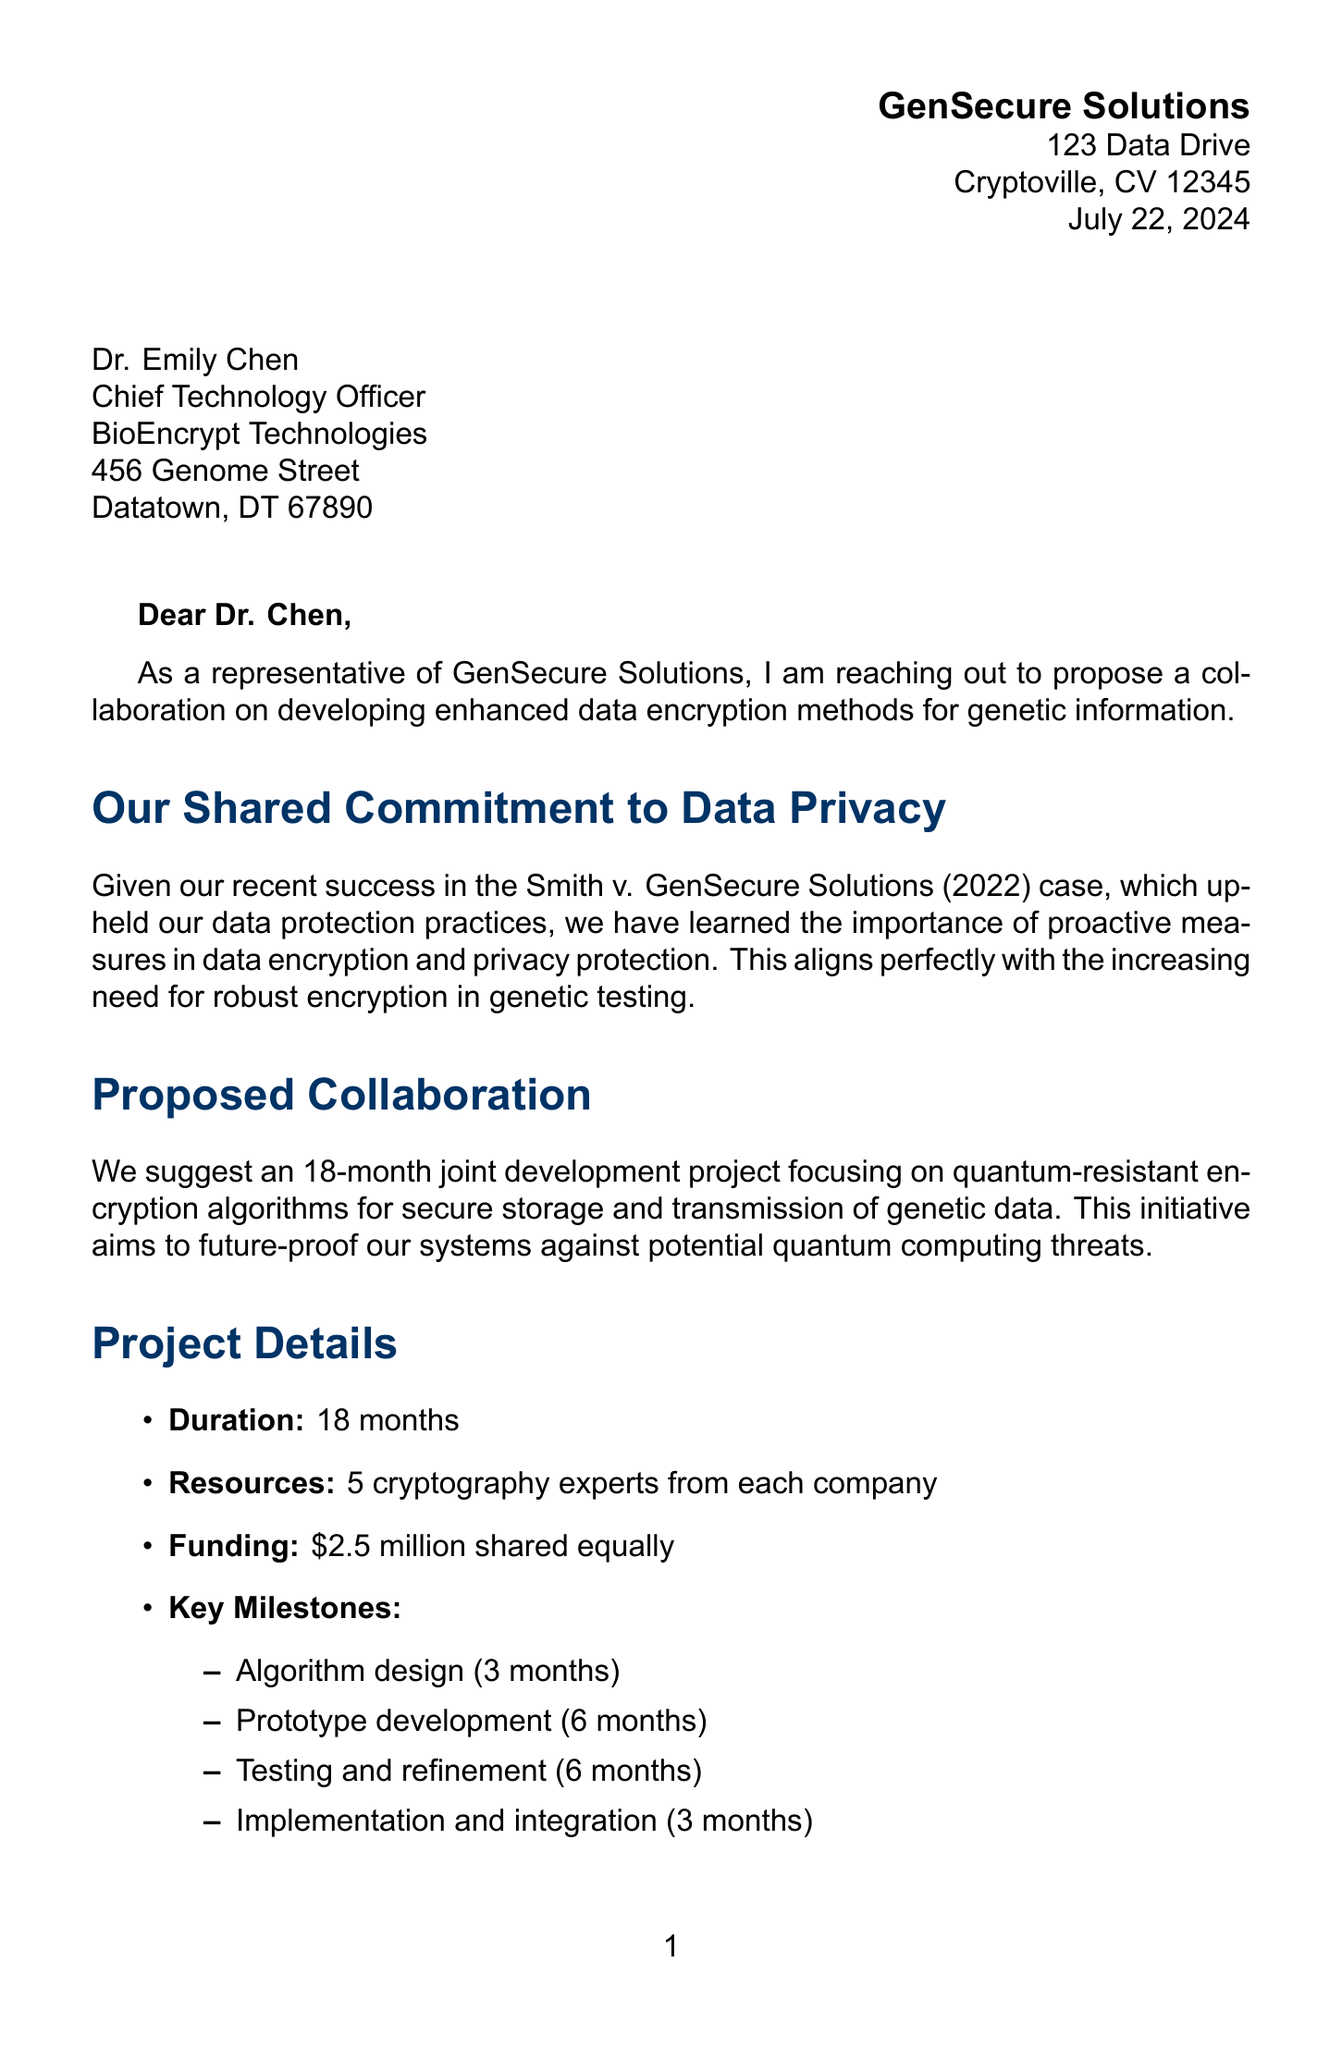What is the name of the sender? The sender of the letter is Michael Thompson, as indicated in the signature section.
Answer: Michael Thompson What is the proposed duration of the project? The letter specifies an 18-month duration for the joint development project.
Answer: 18 months What is the total funding amount for the collaboration? The document states that the funding amount is $2.5 million shared equally between both companies.
Answer: $2.5 million What is the main focus of the proposed collaboration? The main focus of the collaboration is on developing quantum-resistant encryption algorithms for genetic data.
Answer: Quantum-resistant encryption algorithms Which company is being addressed in the letter? The letter is addressed to BioEncrypt Technologies, as mentioned in the recipient's details.
Answer: BioEncrypt Technologies How many cryptography experts will be involved from each company? The letter mentions that 5 cryptography experts from each company will participate.
Answer: 5 What regulatory compliance standards are mentioned in the document? The letter lists current regulations, including GDPR, HIPAA, and CCPA, and mentions the proposed Genetic Information Privacy Act.
Answer: GDPR, HIPAA, CCPA, GIPA What is the consumer concern percentage regarding genetic data privacy? The document states that 78% of consumers express concerns about genetic data privacy.
Answer: 78% What is the next step proposed in the letter? The letter proposes to schedule a video conference to discuss the proposal in detail as the next step.
Answer: Schedule a video conference 